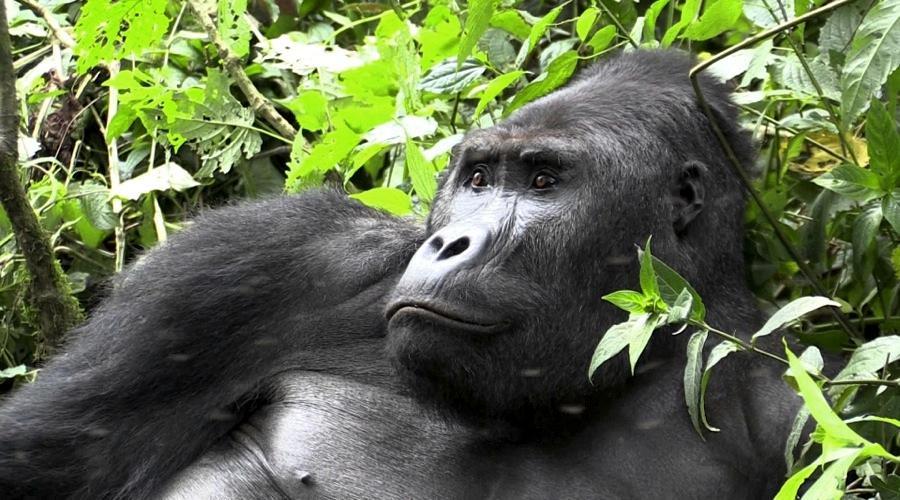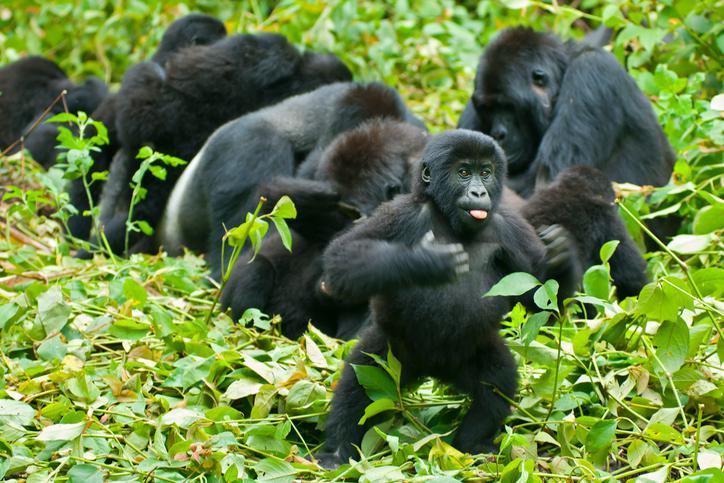The first image is the image on the left, the second image is the image on the right. Given the left and right images, does the statement "One image shows a single ape lying upside-down on its back, with the top of its head facing the camera." hold true? Answer yes or no. No. The first image is the image on the left, the second image is the image on the right. For the images shown, is this caption "The right image contains exactly one gorilla laying on its back surrounded by green foliage." true? Answer yes or no. No. 